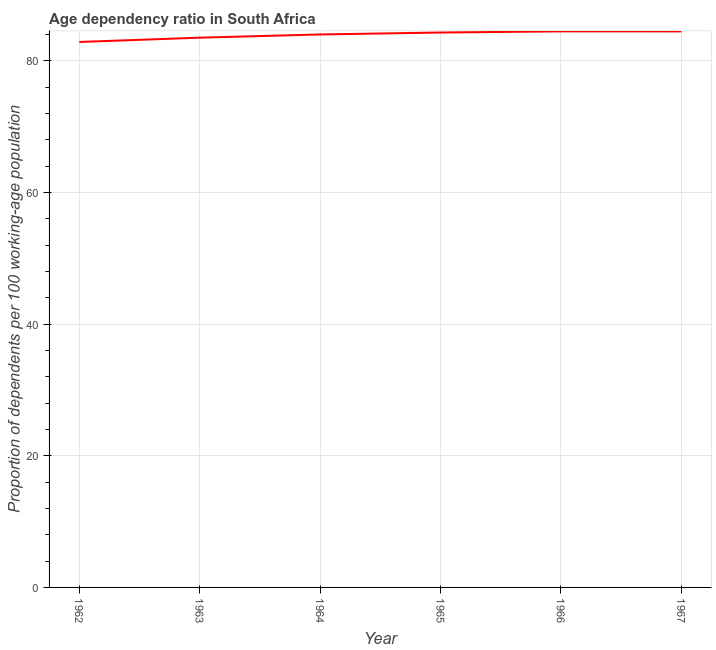What is the age dependency ratio in 1967?
Make the answer very short. 84.48. Across all years, what is the maximum age dependency ratio?
Offer a terse response. 84.49. Across all years, what is the minimum age dependency ratio?
Keep it short and to the point. 82.88. In which year was the age dependency ratio maximum?
Offer a terse response. 1966. What is the sum of the age dependency ratio?
Your response must be concise. 503.72. What is the difference between the age dependency ratio in 1965 and 1967?
Offer a very short reply. -0.17. What is the average age dependency ratio per year?
Your answer should be very brief. 83.95. What is the median age dependency ratio?
Your answer should be compact. 84.17. In how many years, is the age dependency ratio greater than 80 ?
Your answer should be very brief. 6. Do a majority of the years between 1967 and 1963 (inclusive) have age dependency ratio greater than 16 ?
Provide a succinct answer. Yes. What is the ratio of the age dependency ratio in 1963 to that in 1967?
Provide a succinct answer. 0.99. Is the age dependency ratio in 1962 less than that in 1964?
Provide a short and direct response. Yes. What is the difference between the highest and the second highest age dependency ratio?
Keep it short and to the point. 0.01. Is the sum of the age dependency ratio in 1964 and 1967 greater than the maximum age dependency ratio across all years?
Keep it short and to the point. Yes. What is the difference between the highest and the lowest age dependency ratio?
Make the answer very short. 1.61. Does the age dependency ratio monotonically increase over the years?
Keep it short and to the point. No. How many lines are there?
Ensure brevity in your answer.  1. Are the values on the major ticks of Y-axis written in scientific E-notation?
Your answer should be very brief. No. Does the graph contain any zero values?
Make the answer very short. No. What is the title of the graph?
Your answer should be compact. Age dependency ratio in South Africa. What is the label or title of the X-axis?
Your answer should be compact. Year. What is the label or title of the Y-axis?
Provide a succinct answer. Proportion of dependents per 100 working-age population. What is the Proportion of dependents per 100 working-age population of 1962?
Offer a very short reply. 82.88. What is the Proportion of dependents per 100 working-age population in 1963?
Ensure brevity in your answer.  83.53. What is the Proportion of dependents per 100 working-age population of 1964?
Provide a short and direct response. 84.02. What is the Proportion of dependents per 100 working-age population of 1965?
Give a very brief answer. 84.31. What is the Proportion of dependents per 100 working-age population in 1966?
Your answer should be very brief. 84.49. What is the Proportion of dependents per 100 working-age population in 1967?
Your answer should be compact. 84.48. What is the difference between the Proportion of dependents per 100 working-age population in 1962 and 1963?
Provide a succinct answer. -0.65. What is the difference between the Proportion of dependents per 100 working-age population in 1962 and 1964?
Your answer should be compact. -1.14. What is the difference between the Proportion of dependents per 100 working-age population in 1962 and 1965?
Your response must be concise. -1.43. What is the difference between the Proportion of dependents per 100 working-age population in 1962 and 1966?
Give a very brief answer. -1.61. What is the difference between the Proportion of dependents per 100 working-age population in 1962 and 1967?
Offer a terse response. -1.6. What is the difference between the Proportion of dependents per 100 working-age population in 1963 and 1964?
Your response must be concise. -0.49. What is the difference between the Proportion of dependents per 100 working-age population in 1963 and 1965?
Offer a terse response. -0.78. What is the difference between the Proportion of dependents per 100 working-age population in 1963 and 1966?
Your answer should be compact. -0.96. What is the difference between the Proportion of dependents per 100 working-age population in 1963 and 1967?
Offer a very short reply. -0.95. What is the difference between the Proportion of dependents per 100 working-age population in 1964 and 1965?
Offer a very short reply. -0.29. What is the difference between the Proportion of dependents per 100 working-age population in 1964 and 1966?
Keep it short and to the point. -0.47. What is the difference between the Proportion of dependents per 100 working-age population in 1964 and 1967?
Ensure brevity in your answer.  -0.46. What is the difference between the Proportion of dependents per 100 working-age population in 1965 and 1966?
Offer a terse response. -0.18. What is the difference between the Proportion of dependents per 100 working-age population in 1965 and 1967?
Offer a terse response. -0.17. What is the difference between the Proportion of dependents per 100 working-age population in 1966 and 1967?
Provide a succinct answer. 0.01. What is the ratio of the Proportion of dependents per 100 working-age population in 1962 to that in 1963?
Keep it short and to the point. 0.99. What is the ratio of the Proportion of dependents per 100 working-age population in 1962 to that in 1967?
Offer a very short reply. 0.98. What is the ratio of the Proportion of dependents per 100 working-age population in 1963 to that in 1964?
Offer a very short reply. 0.99. What is the ratio of the Proportion of dependents per 100 working-age population in 1963 to that in 1965?
Make the answer very short. 0.99. What is the ratio of the Proportion of dependents per 100 working-age population in 1963 to that in 1966?
Offer a terse response. 0.99. What is the ratio of the Proportion of dependents per 100 working-age population in 1963 to that in 1967?
Make the answer very short. 0.99. What is the ratio of the Proportion of dependents per 100 working-age population in 1964 to that in 1966?
Your answer should be very brief. 0.99. What is the ratio of the Proportion of dependents per 100 working-age population in 1965 to that in 1966?
Provide a succinct answer. 1. What is the ratio of the Proportion of dependents per 100 working-age population in 1966 to that in 1967?
Your response must be concise. 1. 